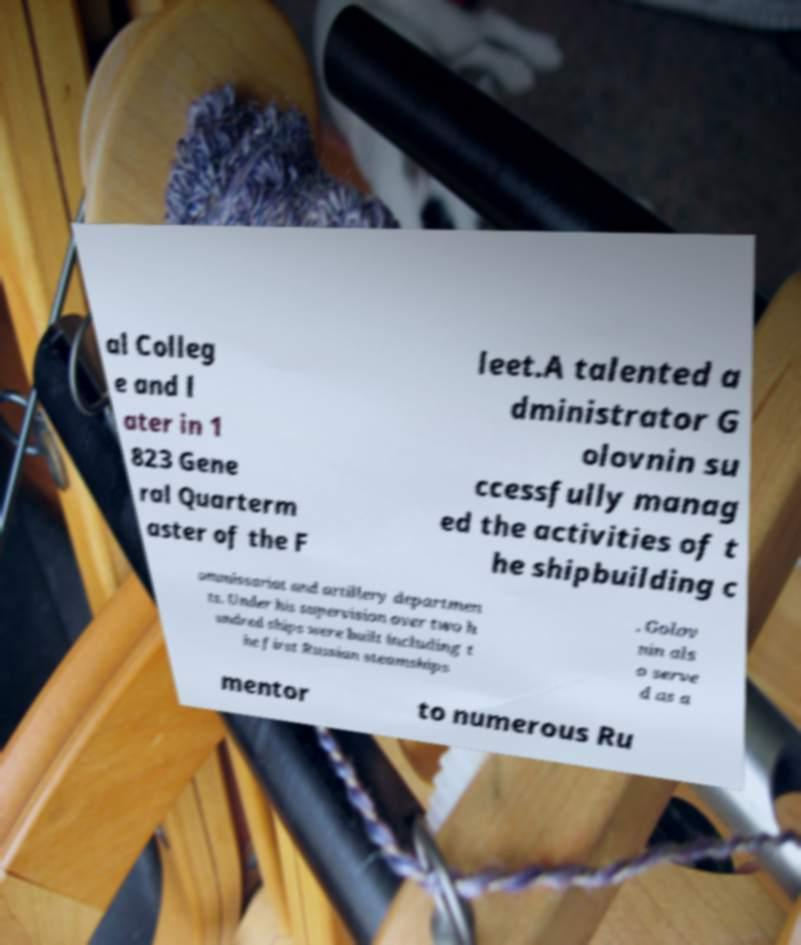Could you assist in decoding the text presented in this image and type it out clearly? al Colleg e and l ater in 1 823 Gene ral Quarterm aster of the F leet.A talented a dministrator G olovnin su ccessfully manag ed the activities of t he shipbuilding c ommissariat and artillery departmen ts. Under his supervision over two h undred ships were built including t he first Russian steamships . Golov nin als o serve d as a mentor to numerous Ru 